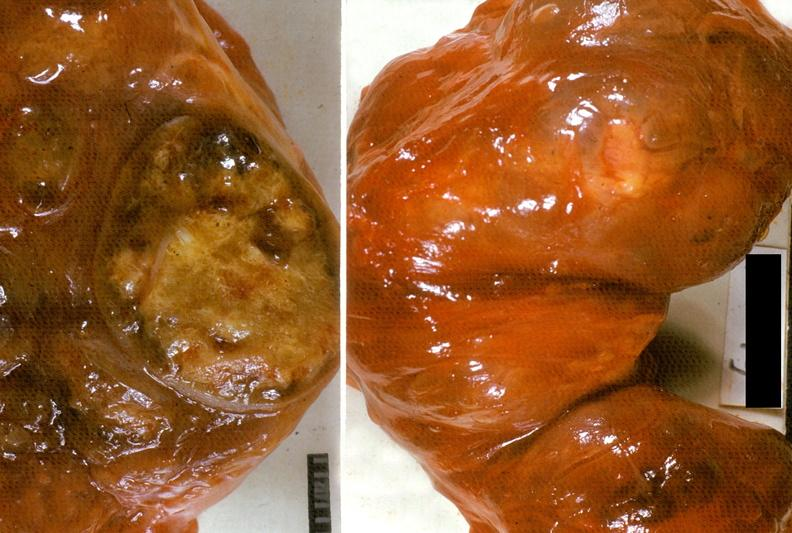s endocrine present?
Answer the question using a single word or phrase. Yes 